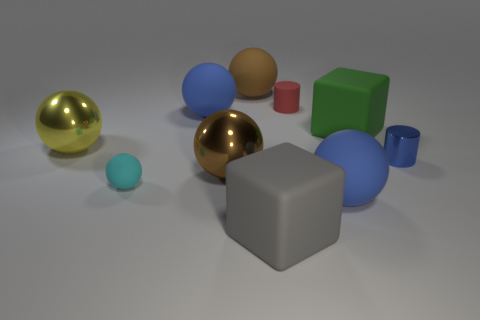Subtract all cyan spheres. How many spheres are left? 5 Subtract all cyan spheres. How many spheres are left? 5 Subtract all purple balls. Subtract all blue blocks. How many balls are left? 6 Subtract all balls. How many objects are left? 4 Add 2 tiny blue shiny cylinders. How many tiny blue shiny cylinders are left? 3 Add 8 brown balls. How many brown balls exist? 10 Subtract 0 gray spheres. How many objects are left? 10 Subtract all small blue objects. Subtract all tiny blue objects. How many objects are left? 8 